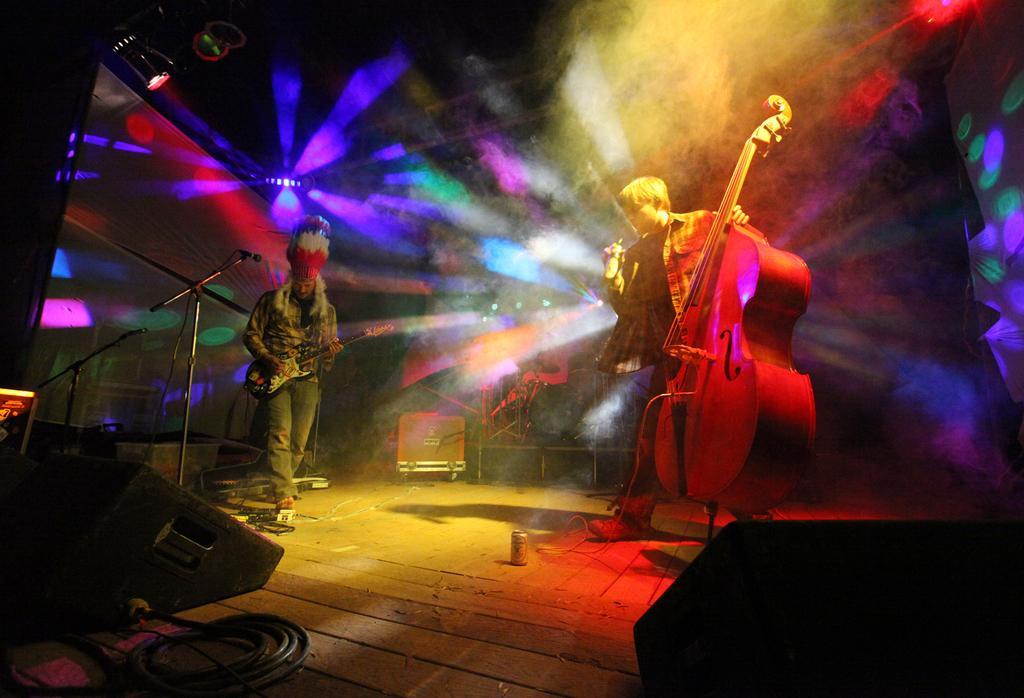Can you describe this image briefly? In this image, we can see a stage. On top of the stage, there are two people are standing. The right side man is playing a violin. And the left side man is playing a guitar. We can see a microphone here and a roof lights. We can found a tin bottle on the floor and a drum here. The right side man is holding a bottle. 